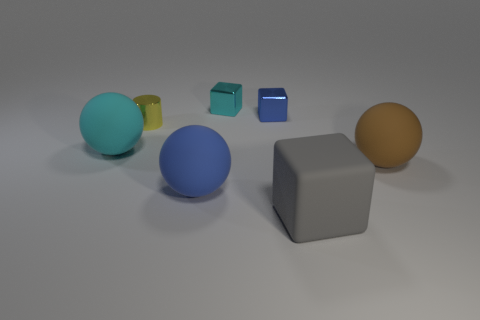Subtract all tiny blue blocks. How many blocks are left? 2 Subtract 1 cubes. How many cubes are left? 2 Add 1 small blocks. How many objects exist? 8 Subtract all cubes. How many objects are left? 4 Subtract 1 gray cubes. How many objects are left? 6 Subtract all yellow metallic objects. Subtract all brown rubber things. How many objects are left? 5 Add 2 shiny cylinders. How many shiny cylinders are left? 3 Add 1 cyan metallic things. How many cyan metallic things exist? 2 